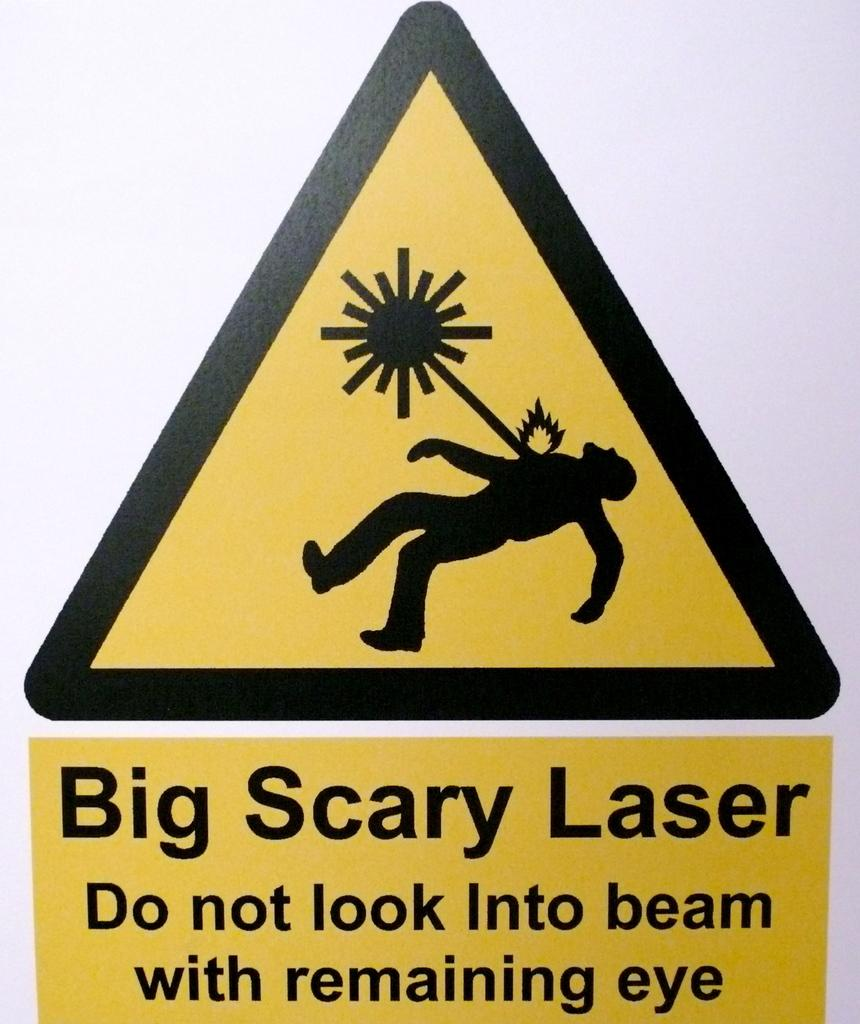<image>
Render a clear and concise summary of the photo. A warning sign warns of big scary laser, do not look into beam. 